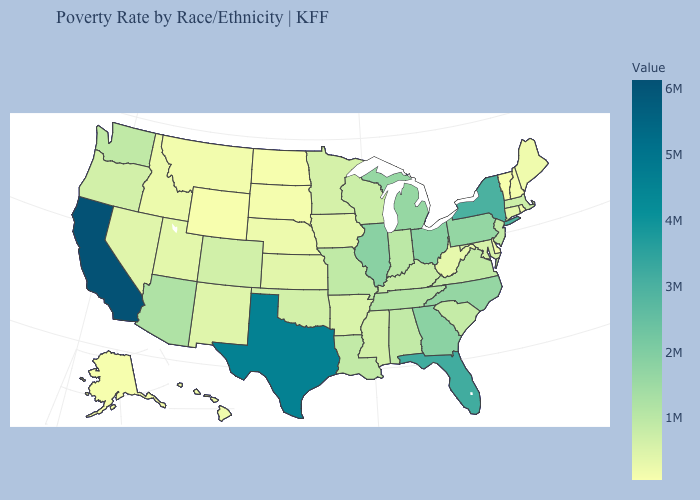Among the states that border New Jersey , does Pennsylvania have the lowest value?
Concise answer only. No. Does the map have missing data?
Short answer required. No. Does Oklahoma have the highest value in the USA?
Write a very short answer. No. Does Illinois have the highest value in the MidWest?
Write a very short answer. Yes. Does West Virginia have a higher value than Tennessee?
Short answer required. No. 